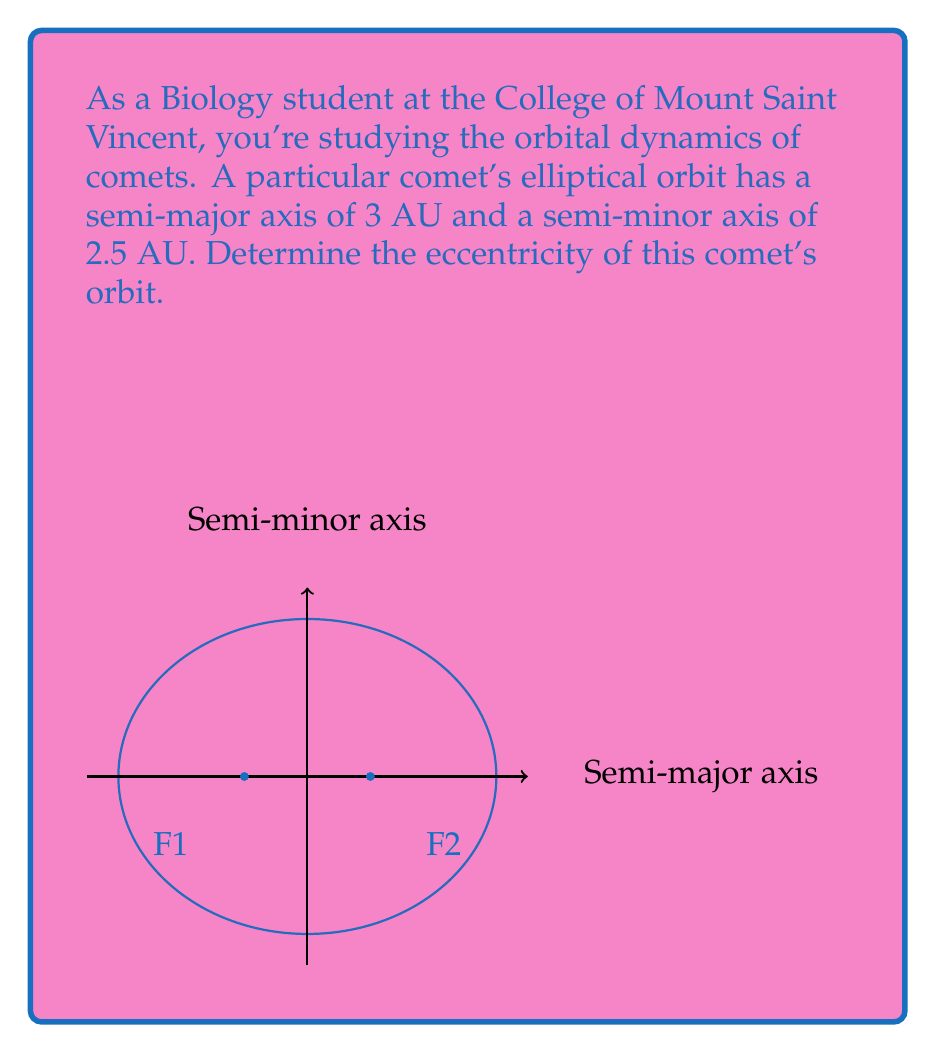Give your solution to this math problem. Let's approach this step-by-step:

1) The eccentricity ($e$) of an ellipse is defined by the formula:

   $$e = \sqrt{1 - \frac{b^2}{a^2}}$$

   where $a$ is the semi-major axis and $b$ is the semi-minor axis.

2) We are given:
   $a = 3$ AU
   $b = 2.5$ AU

3) Let's substitute these values into the formula:

   $$e = \sqrt{1 - \frac{(2.5)^2}{(3)^2}}$$

4) Simplify inside the parentheses:

   $$e = \sqrt{1 - \frac{6.25}{9}}$$

5) Perform the division:

   $$e = \sqrt{1 - 0.6944}$$

6) Subtract:

   $$e = \sqrt{0.3056}$$

7) Take the square root:

   $$e \approx 0.5528$$

Therefore, the eccentricity of the comet's orbit is approximately 0.5528.
Answer: $e \approx 0.5528$ 